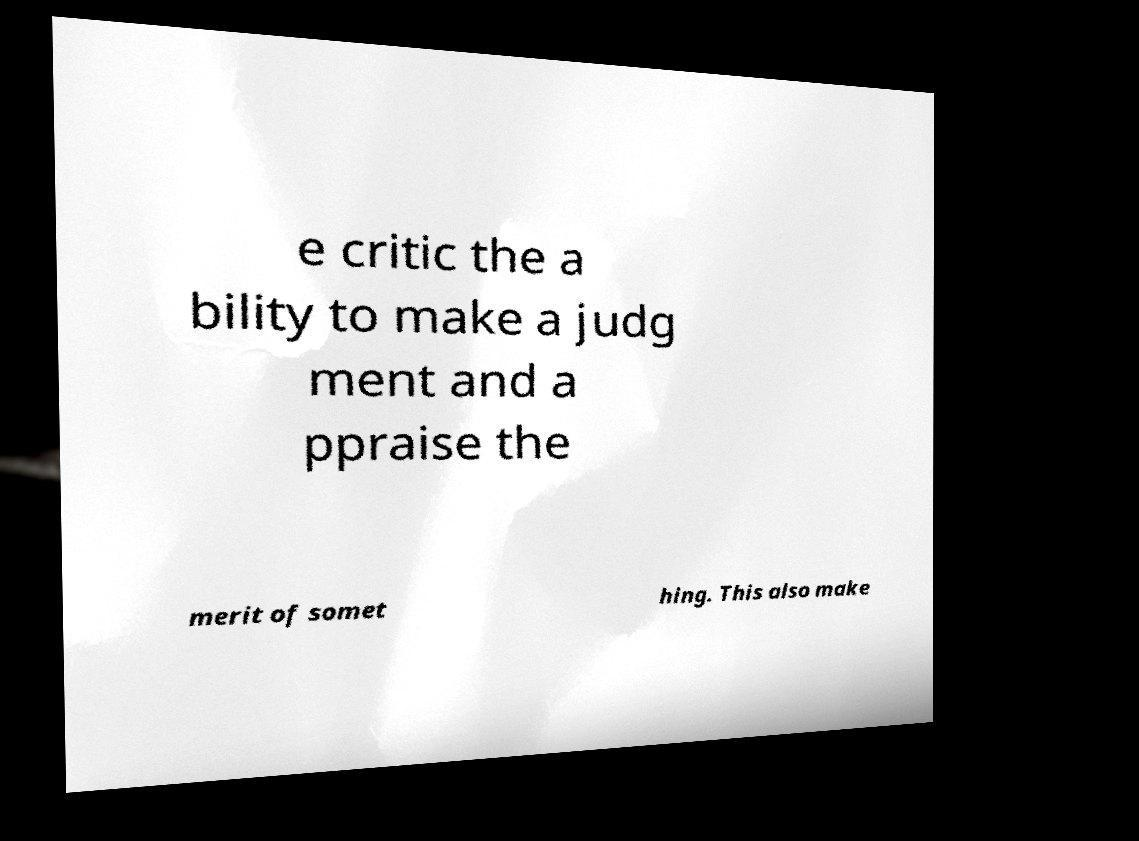What messages or text are displayed in this image? I need them in a readable, typed format. e critic the a bility to make a judg ment and a ppraise the merit of somet hing. This also make 